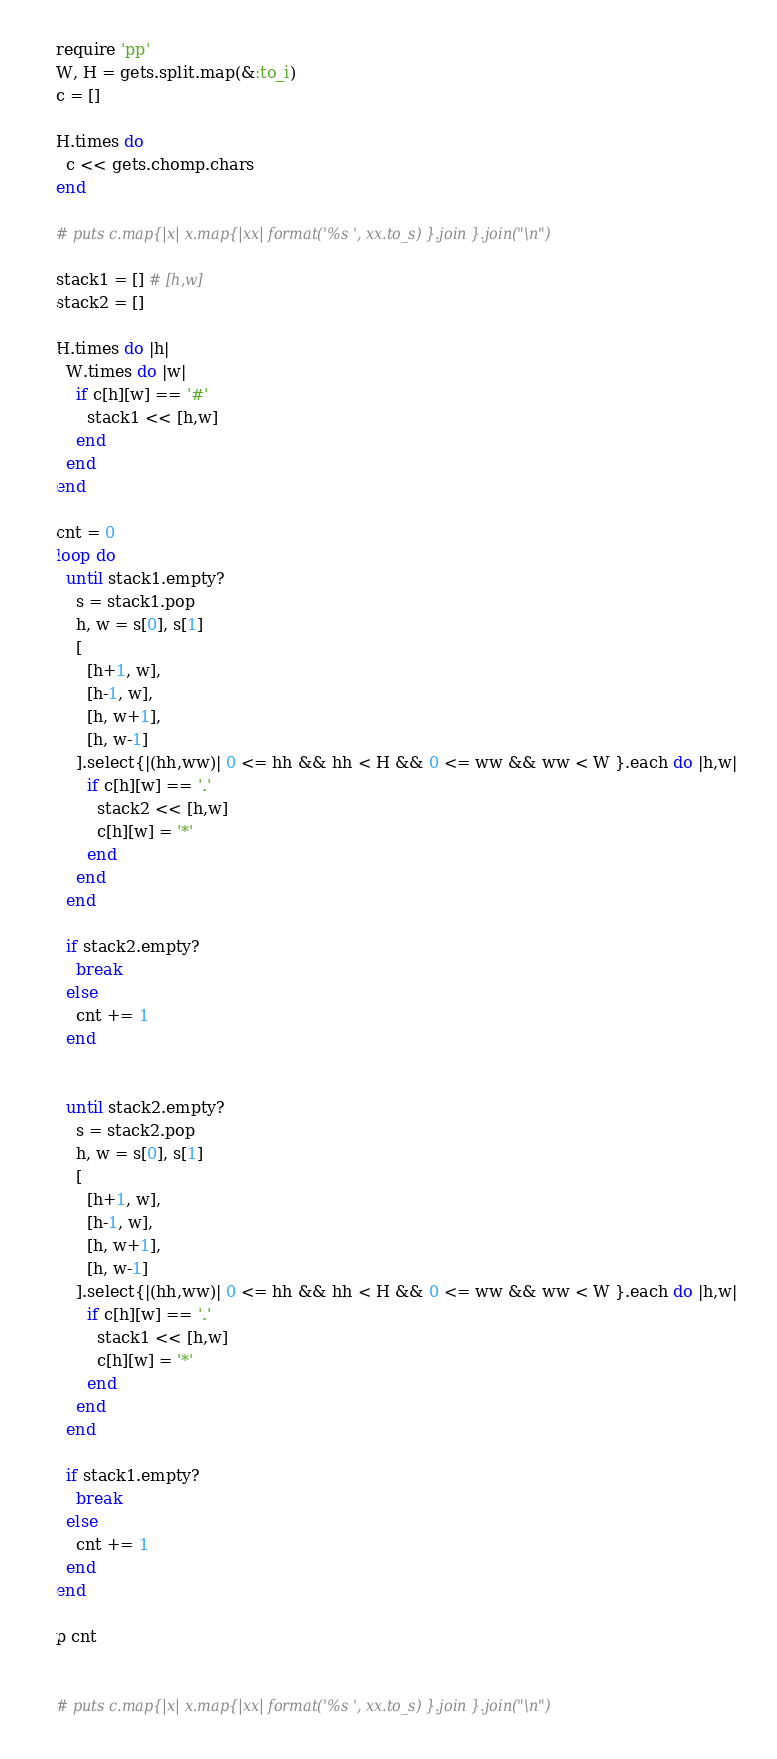<code> <loc_0><loc_0><loc_500><loc_500><_Ruby_>require 'pp'
W, H = gets.split.map(&:to_i)
c = []

H.times do
  c << gets.chomp.chars
end

# puts c.map{|x| x.map{|xx| format('%s ', xx.to_s) }.join }.join("\n")

stack1 = [] # [h,w]
stack2 = []

H.times do |h|
  W.times do |w|
    if c[h][w] == '#'
      stack1 << [h,w]
    end
  end
end

cnt = 0
loop do
  until stack1.empty?
    s = stack1.pop
    h, w = s[0], s[1]
    [
      [h+1, w],
      [h-1, w],
      [h, w+1],
      [h, w-1]
    ].select{|(hh,ww)| 0 <= hh && hh < H && 0 <= ww && ww < W }.each do |h,w|
      if c[h][w] == '.'
        stack2 << [h,w]
        c[h][w] = '*'
      end
    end
  end

  if stack2.empty?
    break
  else
    cnt += 1
  end


  until stack2.empty?
    s = stack2.pop
    h, w = s[0], s[1]
    [
      [h+1, w],
      [h-1, w],
      [h, w+1],
      [h, w-1]
    ].select{|(hh,ww)| 0 <= hh && hh < H && 0 <= ww && ww < W }.each do |h,w|
      if c[h][w] == '.'
        stack1 << [h,w]
        c[h][w] = '*'
      end
    end
  end

  if stack1.empty?
    break
  else
    cnt += 1
  end
end

p cnt


# puts c.map{|x| x.map{|xx| format('%s ', xx.to_s) }.join }.join("\n")






</code> 